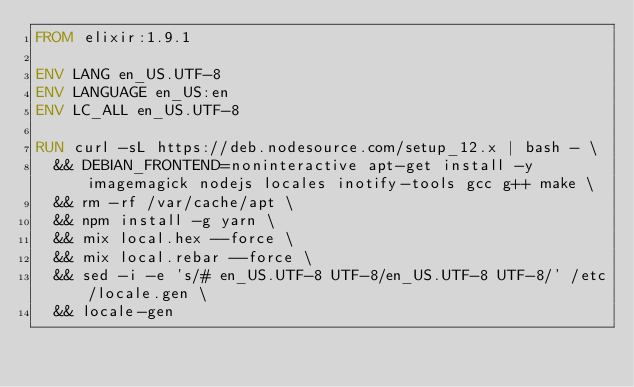Convert code to text. <code><loc_0><loc_0><loc_500><loc_500><_Dockerfile_>FROM elixir:1.9.1

ENV LANG en_US.UTF-8
ENV LANGUAGE en_US:en
ENV LC_ALL en_US.UTF-8

RUN curl -sL https://deb.nodesource.com/setup_12.x | bash - \
  && DEBIAN_FRONTEND=noninteractive apt-get install -y imagemagick nodejs locales inotify-tools gcc g++ make \
  && rm -rf /var/cache/apt \
  && npm install -g yarn \
  && mix local.hex --force \
  && mix local.rebar --force \
  && sed -i -e 's/# en_US.UTF-8 UTF-8/en_US.UTF-8 UTF-8/' /etc/locale.gen \
  && locale-gen</code> 